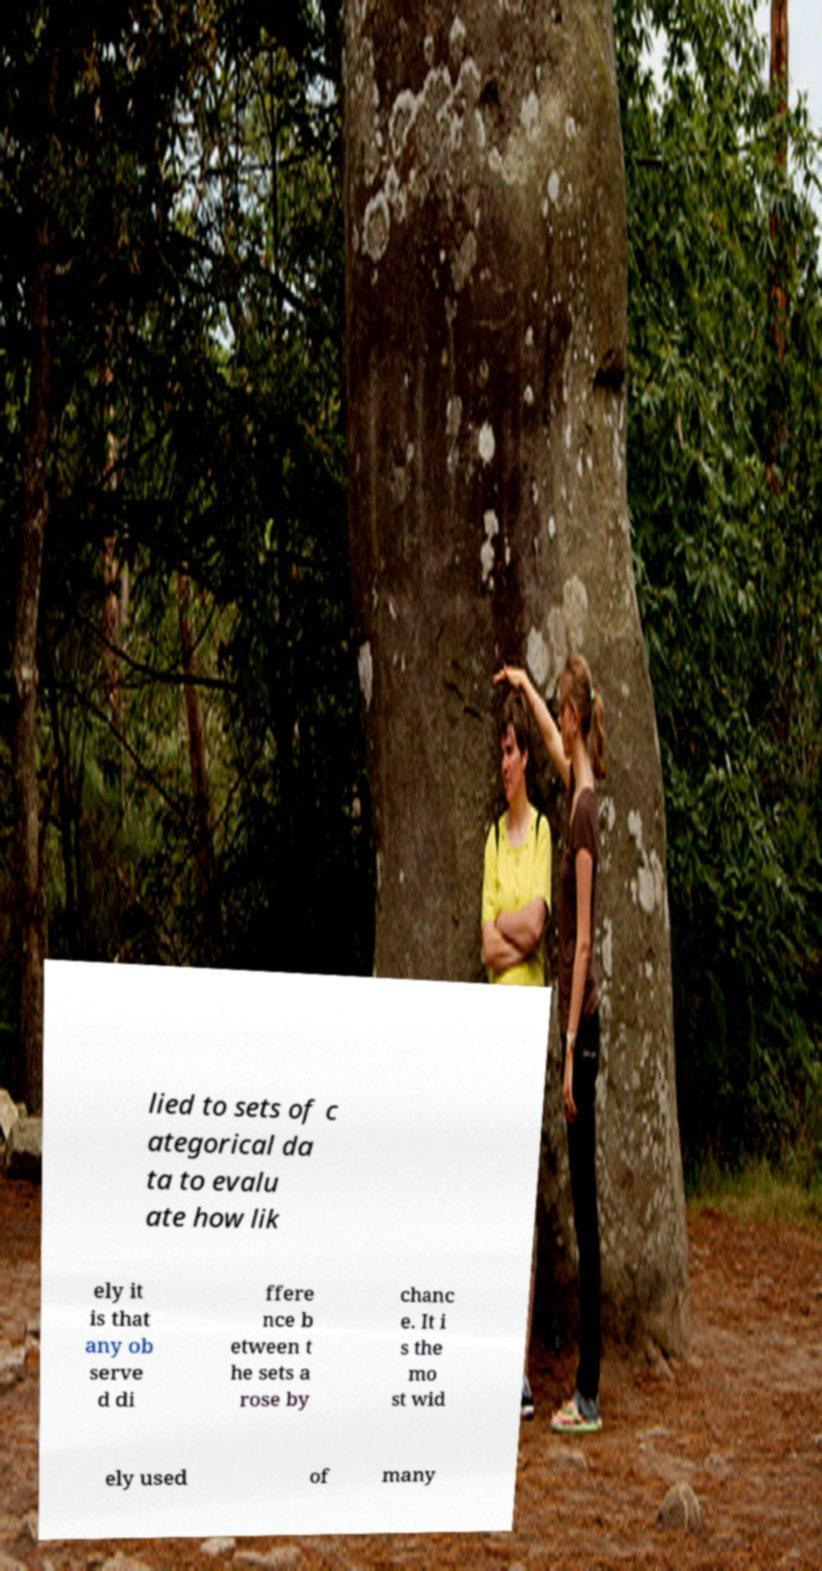Please identify and transcribe the text found in this image. lied to sets of c ategorical da ta to evalu ate how lik ely it is that any ob serve d di ffere nce b etween t he sets a rose by chanc e. It i s the mo st wid ely used of many 